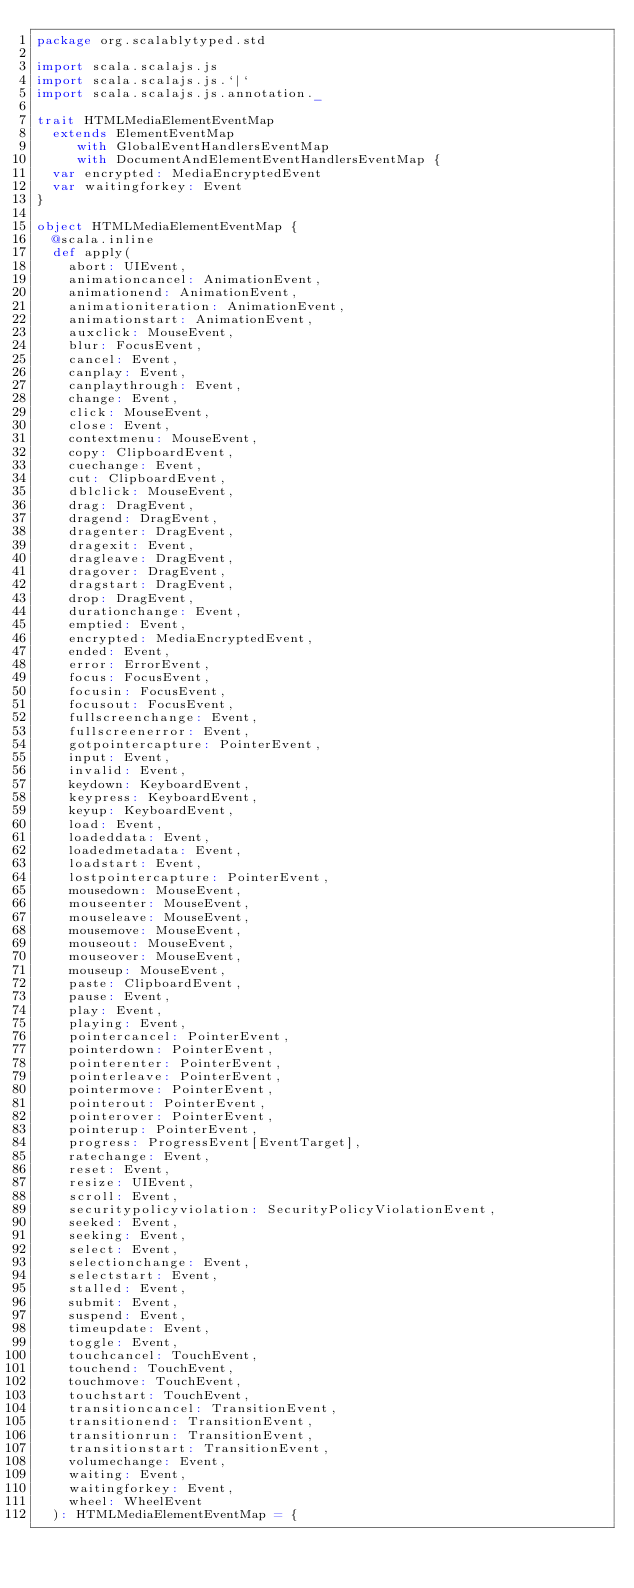Convert code to text. <code><loc_0><loc_0><loc_500><loc_500><_Scala_>package org.scalablytyped.std

import scala.scalajs.js
import scala.scalajs.js.`|`
import scala.scalajs.js.annotation._

trait HTMLMediaElementEventMap
  extends ElementEventMap
     with GlobalEventHandlersEventMap
     with DocumentAndElementEventHandlersEventMap {
  var encrypted: MediaEncryptedEvent
  var waitingforkey: Event
}

object HTMLMediaElementEventMap {
  @scala.inline
  def apply(
    abort: UIEvent,
    animationcancel: AnimationEvent,
    animationend: AnimationEvent,
    animationiteration: AnimationEvent,
    animationstart: AnimationEvent,
    auxclick: MouseEvent,
    blur: FocusEvent,
    cancel: Event,
    canplay: Event,
    canplaythrough: Event,
    change: Event,
    click: MouseEvent,
    close: Event,
    contextmenu: MouseEvent,
    copy: ClipboardEvent,
    cuechange: Event,
    cut: ClipboardEvent,
    dblclick: MouseEvent,
    drag: DragEvent,
    dragend: DragEvent,
    dragenter: DragEvent,
    dragexit: Event,
    dragleave: DragEvent,
    dragover: DragEvent,
    dragstart: DragEvent,
    drop: DragEvent,
    durationchange: Event,
    emptied: Event,
    encrypted: MediaEncryptedEvent,
    ended: Event,
    error: ErrorEvent,
    focus: FocusEvent,
    focusin: FocusEvent,
    focusout: FocusEvent,
    fullscreenchange: Event,
    fullscreenerror: Event,
    gotpointercapture: PointerEvent,
    input: Event,
    invalid: Event,
    keydown: KeyboardEvent,
    keypress: KeyboardEvent,
    keyup: KeyboardEvent,
    load: Event,
    loadeddata: Event,
    loadedmetadata: Event,
    loadstart: Event,
    lostpointercapture: PointerEvent,
    mousedown: MouseEvent,
    mouseenter: MouseEvent,
    mouseleave: MouseEvent,
    mousemove: MouseEvent,
    mouseout: MouseEvent,
    mouseover: MouseEvent,
    mouseup: MouseEvent,
    paste: ClipboardEvent,
    pause: Event,
    play: Event,
    playing: Event,
    pointercancel: PointerEvent,
    pointerdown: PointerEvent,
    pointerenter: PointerEvent,
    pointerleave: PointerEvent,
    pointermove: PointerEvent,
    pointerout: PointerEvent,
    pointerover: PointerEvent,
    pointerup: PointerEvent,
    progress: ProgressEvent[EventTarget],
    ratechange: Event,
    reset: Event,
    resize: UIEvent,
    scroll: Event,
    securitypolicyviolation: SecurityPolicyViolationEvent,
    seeked: Event,
    seeking: Event,
    select: Event,
    selectionchange: Event,
    selectstart: Event,
    stalled: Event,
    submit: Event,
    suspend: Event,
    timeupdate: Event,
    toggle: Event,
    touchcancel: TouchEvent,
    touchend: TouchEvent,
    touchmove: TouchEvent,
    touchstart: TouchEvent,
    transitioncancel: TransitionEvent,
    transitionend: TransitionEvent,
    transitionrun: TransitionEvent,
    transitionstart: TransitionEvent,
    volumechange: Event,
    waiting: Event,
    waitingforkey: Event,
    wheel: WheelEvent
  ): HTMLMediaElementEventMap = {</code> 